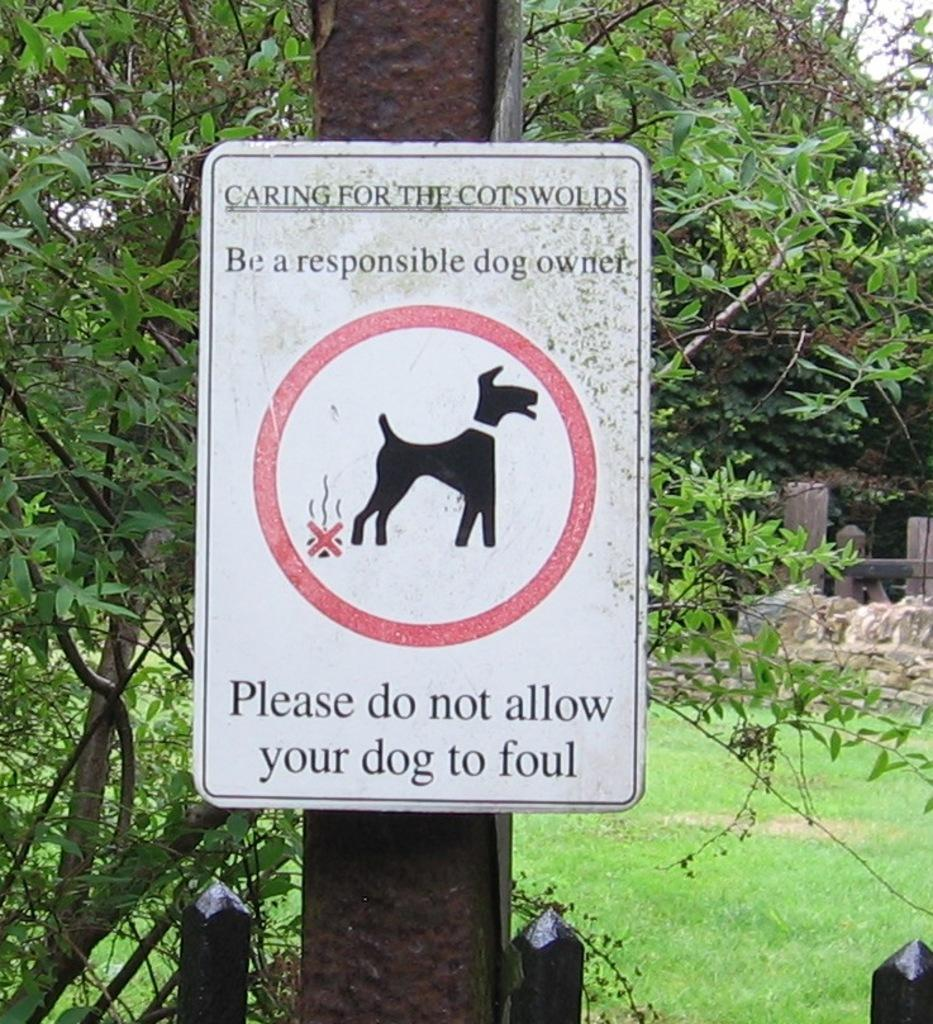What is on the pole in the image? There is a board on a pole in the image. What type of vegetation can be seen in the image? There are trees and green grass in the image. What is visible in the sky in the image? Clouds are visible in the sky in the image. What channel is the board on the pole broadcasting in the image? There is no indication of a broadcast or channel in the image; it simply shows a board on a pole. How many cows are grazing in the green grass in the image? There are no cows present in the image; it only features a board on a pole, trees, green grass, and clouds in the sky. 